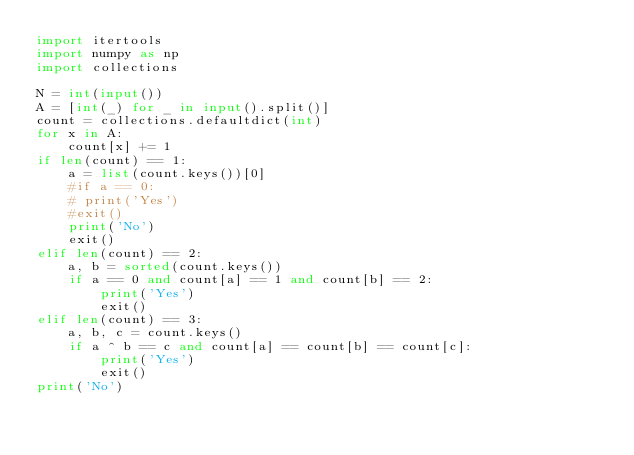<code> <loc_0><loc_0><loc_500><loc_500><_Python_>import itertools
import numpy as np
import collections

N = int(input())
A = [int(_) for _ in input().split()]
count = collections.defaultdict(int)
for x in A:
    count[x] += 1
if len(count) == 1:
    a = list(count.keys())[0]
    #if a == 0:
    # print('Yes')
    #exit()
    print('No')
    exit()
elif len(count) == 2:
    a, b = sorted(count.keys())
    if a == 0 and count[a] == 1 and count[b] == 2:
        print('Yes')
        exit()
elif len(count) == 3:
    a, b, c = count.keys()
    if a ^ b == c and count[a] == count[b] == count[c]:
        print('Yes')
        exit()
print('No')
</code> 